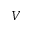Convert formula to latex. <formula><loc_0><loc_0><loc_500><loc_500>V</formula> 